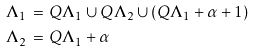Convert formula to latex. <formula><loc_0><loc_0><loc_500><loc_500>\Lambda _ { 1 } \, & = \, Q \Lambda _ { 1 } \cup Q \Lambda _ { 2 } \cup ( Q \Lambda _ { 1 } + \alpha + 1 ) \\ \Lambda _ { 2 } \, & = \, Q \Lambda _ { 1 } + \alpha</formula> 